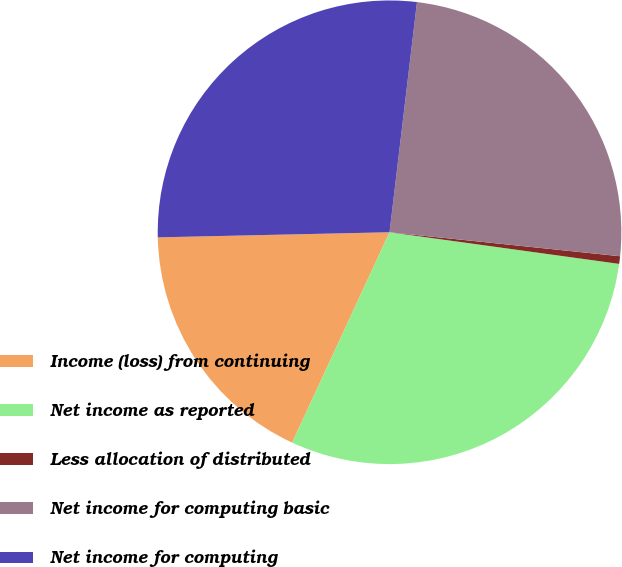<chart> <loc_0><loc_0><loc_500><loc_500><pie_chart><fcel>Income (loss) from continuing<fcel>Net income as reported<fcel>Less allocation of distributed<fcel>Net income for computing basic<fcel>Net income for computing<nl><fcel>17.75%<fcel>29.72%<fcel>0.53%<fcel>24.76%<fcel>27.24%<nl></chart> 